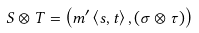Convert formula to latex. <formula><loc_0><loc_0><loc_500><loc_500>S \otimes T = \left ( m ^ { \prime } \left \langle s , t \right \rangle , \left ( \sigma \otimes \tau \right ) \right )</formula> 